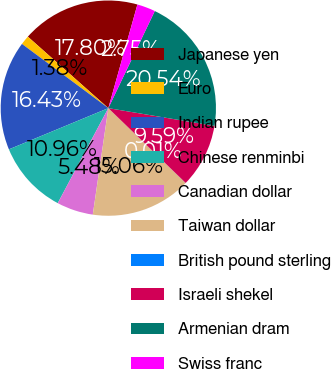Convert chart. <chart><loc_0><loc_0><loc_500><loc_500><pie_chart><fcel>Japanese yen<fcel>Euro<fcel>Indian rupee<fcel>Chinese renminbi<fcel>Canadian dollar<fcel>Taiwan dollar<fcel>British pound sterling<fcel>Israeli shekel<fcel>Armenian dram<fcel>Swiss franc<nl><fcel>17.8%<fcel>1.38%<fcel>16.43%<fcel>10.96%<fcel>5.48%<fcel>15.06%<fcel>0.01%<fcel>9.59%<fcel>20.54%<fcel>2.75%<nl></chart> 